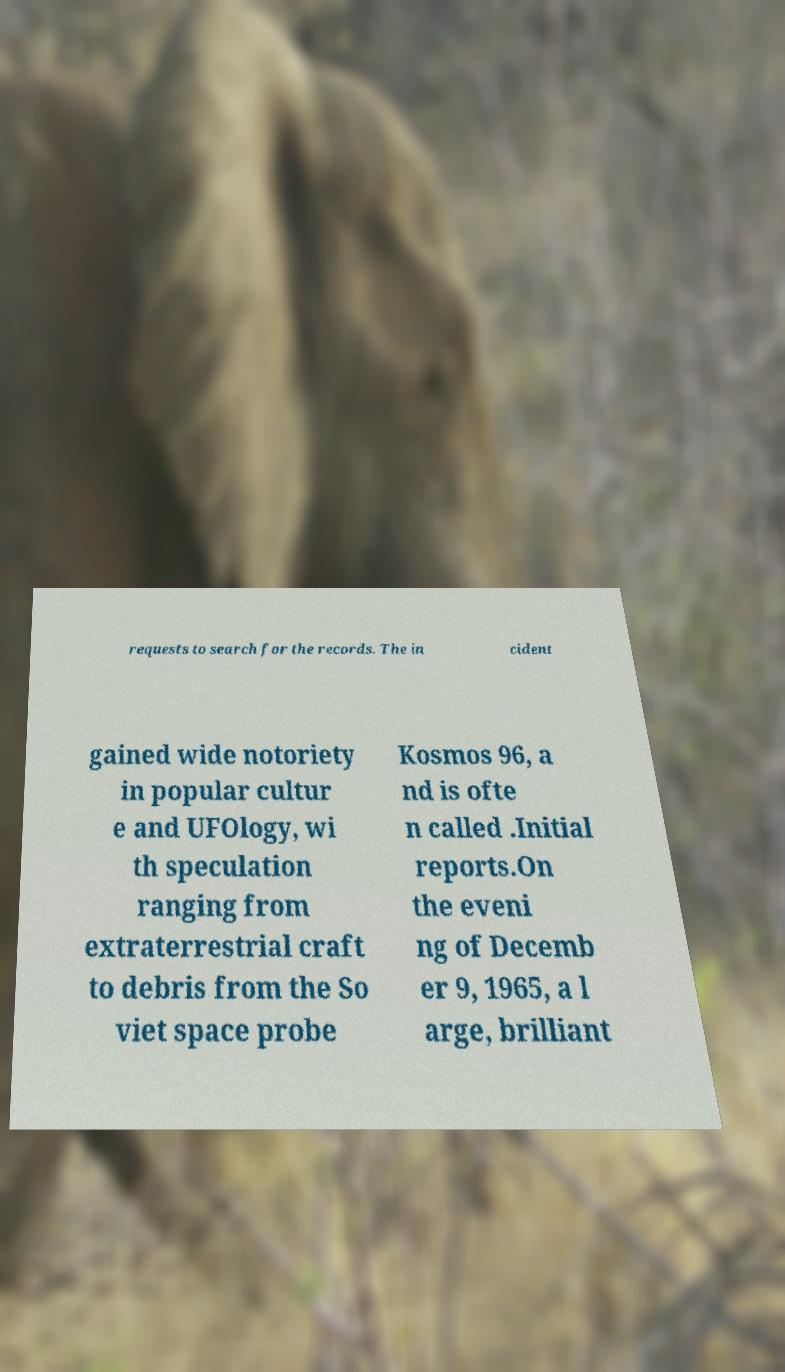Can you read and provide the text displayed in the image?This photo seems to have some interesting text. Can you extract and type it out for me? requests to search for the records. The in cident gained wide notoriety in popular cultur e and UFOlogy, wi th speculation ranging from extraterrestrial craft to debris from the So viet space probe Kosmos 96, a nd is ofte n called .Initial reports.On the eveni ng of Decemb er 9, 1965, a l arge, brilliant 